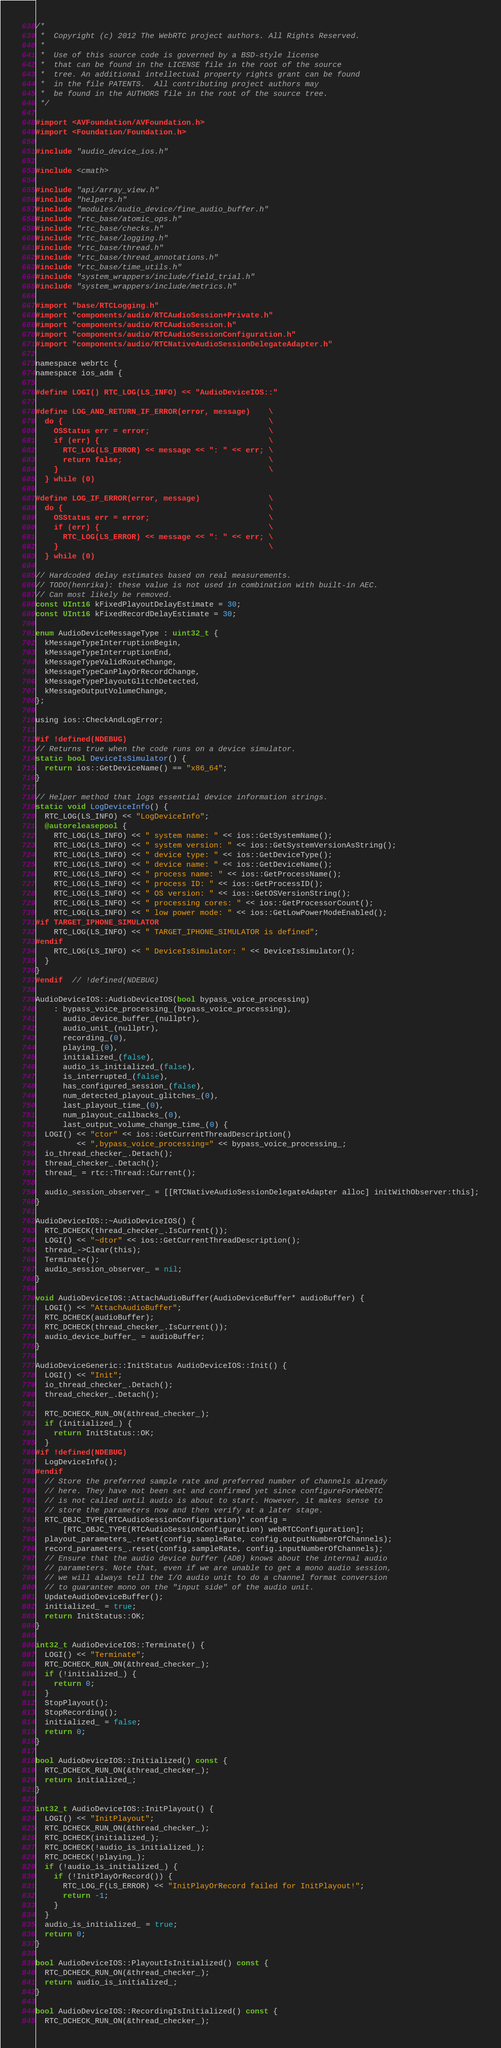<code> <loc_0><loc_0><loc_500><loc_500><_ObjectiveC_>/*
 *  Copyright (c) 2012 The WebRTC project authors. All Rights Reserved.
 *
 *  Use of this source code is governed by a BSD-style license
 *  that can be found in the LICENSE file in the root of the source
 *  tree. An additional intellectual property rights grant can be found
 *  in the file PATENTS.  All contributing project authors may
 *  be found in the AUTHORS file in the root of the source tree.
 */

#import <AVFoundation/AVFoundation.h>
#import <Foundation/Foundation.h>

#include "audio_device_ios.h"

#include <cmath>

#include "api/array_view.h"
#include "helpers.h"
#include "modules/audio_device/fine_audio_buffer.h"
#include "rtc_base/atomic_ops.h"
#include "rtc_base/checks.h"
#include "rtc_base/logging.h"
#include "rtc_base/thread.h"
#include "rtc_base/thread_annotations.h"
#include "rtc_base/time_utils.h"
#include "system_wrappers/include/field_trial.h"
#include "system_wrappers/include/metrics.h"

#import "base/RTCLogging.h"
#import "components/audio/RTCAudioSession+Private.h"
#import "components/audio/RTCAudioSession.h"
#import "components/audio/RTCAudioSessionConfiguration.h"
#import "components/audio/RTCNativeAudioSessionDelegateAdapter.h"

namespace webrtc {
namespace ios_adm {

#define LOGI() RTC_LOG(LS_INFO) << "AudioDeviceIOS::"

#define LOG_AND_RETURN_IF_ERROR(error, message)    \
  do {                                             \
    OSStatus err = error;                          \
    if (err) {                                     \
      RTC_LOG(LS_ERROR) << message << ": " << err; \
      return false;                                \
    }                                              \
  } while (0)

#define LOG_IF_ERROR(error, message)               \
  do {                                             \
    OSStatus err = error;                          \
    if (err) {                                     \
      RTC_LOG(LS_ERROR) << message << ": " << err; \
    }                                              \
  } while (0)

// Hardcoded delay estimates based on real measurements.
// TODO(henrika): these value is not used in combination with built-in AEC.
// Can most likely be removed.
const UInt16 kFixedPlayoutDelayEstimate = 30;
const UInt16 kFixedRecordDelayEstimate = 30;

enum AudioDeviceMessageType : uint32_t {
  kMessageTypeInterruptionBegin,
  kMessageTypeInterruptionEnd,
  kMessageTypeValidRouteChange,
  kMessageTypeCanPlayOrRecordChange,
  kMessageTypePlayoutGlitchDetected,
  kMessageOutputVolumeChange,
};

using ios::CheckAndLogError;

#if !defined(NDEBUG)
// Returns true when the code runs on a device simulator.
static bool DeviceIsSimulator() {
  return ios::GetDeviceName() == "x86_64";
}

// Helper method that logs essential device information strings.
static void LogDeviceInfo() {
  RTC_LOG(LS_INFO) << "LogDeviceInfo";
  @autoreleasepool {
    RTC_LOG(LS_INFO) << " system name: " << ios::GetSystemName();
    RTC_LOG(LS_INFO) << " system version: " << ios::GetSystemVersionAsString();
    RTC_LOG(LS_INFO) << " device type: " << ios::GetDeviceType();
    RTC_LOG(LS_INFO) << " device name: " << ios::GetDeviceName();
    RTC_LOG(LS_INFO) << " process name: " << ios::GetProcessName();
    RTC_LOG(LS_INFO) << " process ID: " << ios::GetProcessID();
    RTC_LOG(LS_INFO) << " OS version: " << ios::GetOSVersionString();
    RTC_LOG(LS_INFO) << " processing cores: " << ios::GetProcessorCount();
    RTC_LOG(LS_INFO) << " low power mode: " << ios::GetLowPowerModeEnabled();
#if TARGET_IPHONE_SIMULATOR
    RTC_LOG(LS_INFO) << " TARGET_IPHONE_SIMULATOR is defined";
#endif
    RTC_LOG(LS_INFO) << " DeviceIsSimulator: " << DeviceIsSimulator();
  }
}
#endif  // !defined(NDEBUG)

AudioDeviceIOS::AudioDeviceIOS(bool bypass_voice_processing)
    : bypass_voice_processing_(bypass_voice_processing),
      audio_device_buffer_(nullptr),
      audio_unit_(nullptr),
      recording_(0),
      playing_(0),
      initialized_(false),
      audio_is_initialized_(false),
      is_interrupted_(false),
      has_configured_session_(false),
      num_detected_playout_glitches_(0),
      last_playout_time_(0),
      num_playout_callbacks_(0),
      last_output_volume_change_time_(0) {
  LOGI() << "ctor" << ios::GetCurrentThreadDescription()
         << ",bypass_voice_processing=" << bypass_voice_processing_;
  io_thread_checker_.Detach();
  thread_checker_.Detach();
  thread_ = rtc::Thread::Current();

  audio_session_observer_ = [[RTCNativeAudioSessionDelegateAdapter alloc] initWithObserver:this];
}

AudioDeviceIOS::~AudioDeviceIOS() {
  RTC_DCHECK(thread_checker_.IsCurrent());
  LOGI() << "~dtor" << ios::GetCurrentThreadDescription();
  thread_->Clear(this);
  Terminate();
  audio_session_observer_ = nil;
}

void AudioDeviceIOS::AttachAudioBuffer(AudioDeviceBuffer* audioBuffer) {
  LOGI() << "AttachAudioBuffer";
  RTC_DCHECK(audioBuffer);
  RTC_DCHECK(thread_checker_.IsCurrent());
  audio_device_buffer_ = audioBuffer;
}

AudioDeviceGeneric::InitStatus AudioDeviceIOS::Init() {
  LOGI() << "Init";
  io_thread_checker_.Detach();
  thread_checker_.Detach();

  RTC_DCHECK_RUN_ON(&thread_checker_);
  if (initialized_) {
    return InitStatus::OK;
  }
#if !defined(NDEBUG)
  LogDeviceInfo();
#endif
  // Store the preferred sample rate and preferred number of channels already
  // here. They have not been set and confirmed yet since configureForWebRTC
  // is not called until audio is about to start. However, it makes sense to
  // store the parameters now and then verify at a later stage.
  RTC_OBJC_TYPE(RTCAudioSessionConfiguration)* config =
      [RTC_OBJC_TYPE(RTCAudioSessionConfiguration) webRTCConfiguration];
  playout_parameters_.reset(config.sampleRate, config.outputNumberOfChannels);
  record_parameters_.reset(config.sampleRate, config.inputNumberOfChannels);
  // Ensure that the audio device buffer (ADB) knows about the internal audio
  // parameters. Note that, even if we are unable to get a mono audio session,
  // we will always tell the I/O audio unit to do a channel format conversion
  // to guarantee mono on the "input side" of the audio unit.
  UpdateAudioDeviceBuffer();
  initialized_ = true;
  return InitStatus::OK;
}

int32_t AudioDeviceIOS::Terminate() {
  LOGI() << "Terminate";
  RTC_DCHECK_RUN_ON(&thread_checker_);
  if (!initialized_) {
    return 0;
  }
  StopPlayout();
  StopRecording();
  initialized_ = false;
  return 0;
}

bool AudioDeviceIOS::Initialized() const {
  RTC_DCHECK_RUN_ON(&thread_checker_);
  return initialized_;
}

int32_t AudioDeviceIOS::InitPlayout() {
  LOGI() << "InitPlayout";
  RTC_DCHECK_RUN_ON(&thread_checker_);
  RTC_DCHECK(initialized_);
  RTC_DCHECK(!audio_is_initialized_);
  RTC_DCHECK(!playing_);
  if (!audio_is_initialized_) {
    if (!InitPlayOrRecord()) {
      RTC_LOG_F(LS_ERROR) << "InitPlayOrRecord failed for InitPlayout!";
      return -1;
    }
  }
  audio_is_initialized_ = true;
  return 0;
}

bool AudioDeviceIOS::PlayoutIsInitialized() const {
  RTC_DCHECK_RUN_ON(&thread_checker_);
  return audio_is_initialized_;
}

bool AudioDeviceIOS::RecordingIsInitialized() const {
  RTC_DCHECK_RUN_ON(&thread_checker_);</code> 